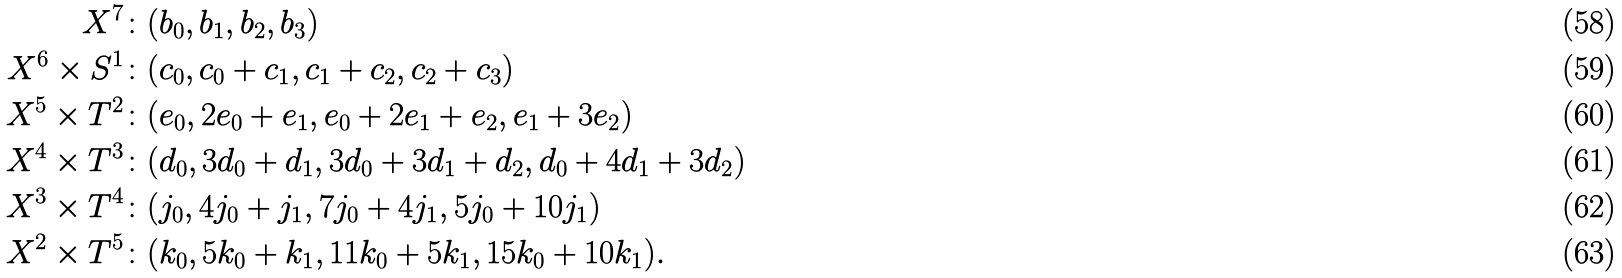Convert formula to latex. <formula><loc_0><loc_0><loc_500><loc_500>X ^ { 7 } & \colon ( b _ { 0 } , b _ { 1 } , b _ { 2 } , b _ { 3 } ) \\ X ^ { 6 } \times S ^ { 1 } & \colon ( c _ { 0 } , c _ { 0 } + c _ { 1 } , c _ { 1 } + c _ { 2 } , c _ { 2 } + c _ { 3 } ) \\ X ^ { 5 } \times T ^ { 2 } & \colon ( e _ { 0 } , 2 e _ { 0 } + e _ { 1 } , e _ { 0 } + 2 e _ { 1 } + e _ { 2 } , e _ { 1 } + 3 e _ { 2 } ) \\ X ^ { 4 } \times T ^ { 3 } & \colon ( d _ { 0 } , 3 d _ { 0 } + d _ { 1 } , 3 d _ { 0 } + 3 d _ { 1 } + d _ { 2 } , d _ { 0 } + 4 d _ { 1 } + 3 d _ { 2 } ) \\ X ^ { 3 } \times T ^ { 4 } & \colon ( j _ { 0 } , 4 j _ { 0 } + j _ { 1 } , 7 j _ { 0 } + 4 j _ { 1 } , 5 j _ { 0 } + 1 0 j _ { 1 } ) \\ X ^ { 2 } \times T ^ { 5 } & \colon ( k _ { 0 } , 5 k _ { 0 } + k _ { 1 } , 1 1 k _ { 0 } + 5 k _ { 1 } , 1 5 k _ { 0 } + 1 0 k _ { 1 } ) .</formula> 